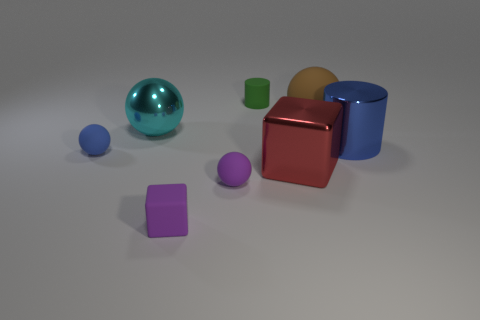Are there any other things of the same color as the matte cube? Yes, the matte cube is green, and there is also a smaller object in the background with a similar shade of green. 